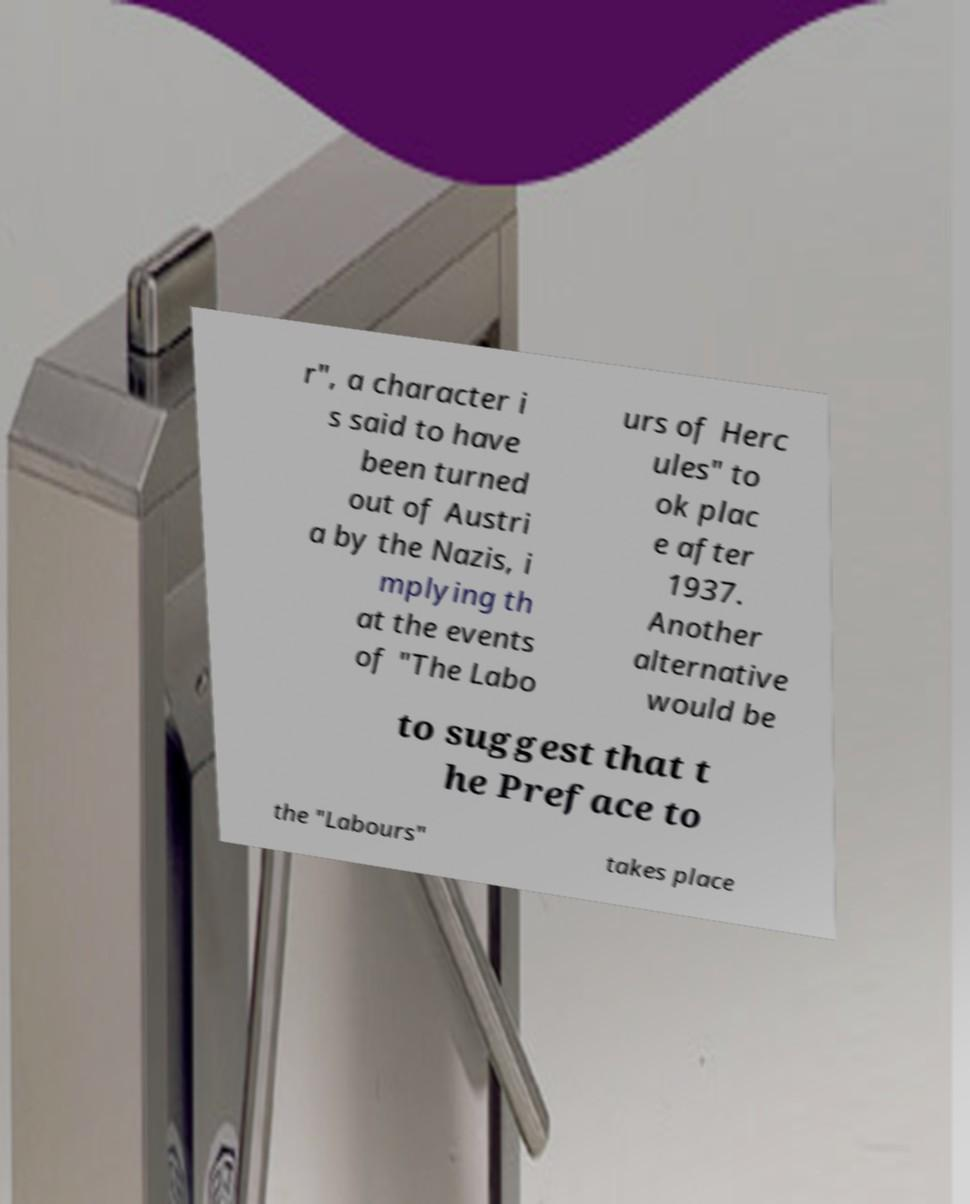Can you accurately transcribe the text from the provided image for me? r", a character i s said to have been turned out of Austri a by the Nazis, i mplying th at the events of "The Labo urs of Herc ules" to ok plac e after 1937. Another alternative would be to suggest that t he Preface to the "Labours" takes place 